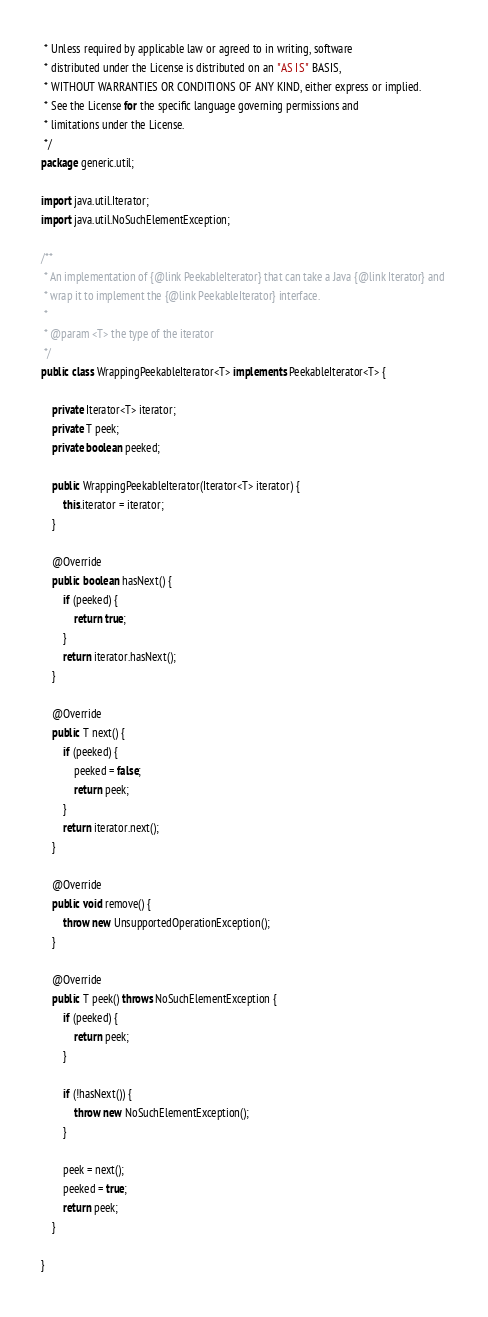<code> <loc_0><loc_0><loc_500><loc_500><_Java_> * Unless required by applicable law or agreed to in writing, software
 * distributed under the License is distributed on an "AS IS" BASIS,
 * WITHOUT WARRANTIES OR CONDITIONS OF ANY KIND, either express or implied.
 * See the License for the specific language governing permissions and
 * limitations under the License.
 */
package generic.util;

import java.util.Iterator;
import java.util.NoSuchElementException;

/**
 * An implementation of {@link PeekableIterator} that can take a Java {@link Iterator} and 
 * wrap it to implement the {@link PeekableIterator} interface.
 *
 * @param <T> the type of the iterator
 */
public class WrappingPeekableIterator<T> implements PeekableIterator<T> {

	private Iterator<T> iterator;
	private T peek;
	private boolean peeked;

	public WrappingPeekableIterator(Iterator<T> iterator) {
		this.iterator = iterator;
	}

	@Override
	public boolean hasNext() {
		if (peeked) {
			return true;
		}
		return iterator.hasNext();
	}

	@Override
	public T next() {
		if (peeked) {
			peeked = false;
			return peek;
		}
		return iterator.next();
	}

	@Override
	public void remove() {
		throw new UnsupportedOperationException();
	}

	@Override
	public T peek() throws NoSuchElementException {
		if (peeked) {
			return peek;
		}

		if (!hasNext()) {
			throw new NoSuchElementException();
		}

		peek = next();
		peeked = true;
		return peek;
	}

}
</code> 